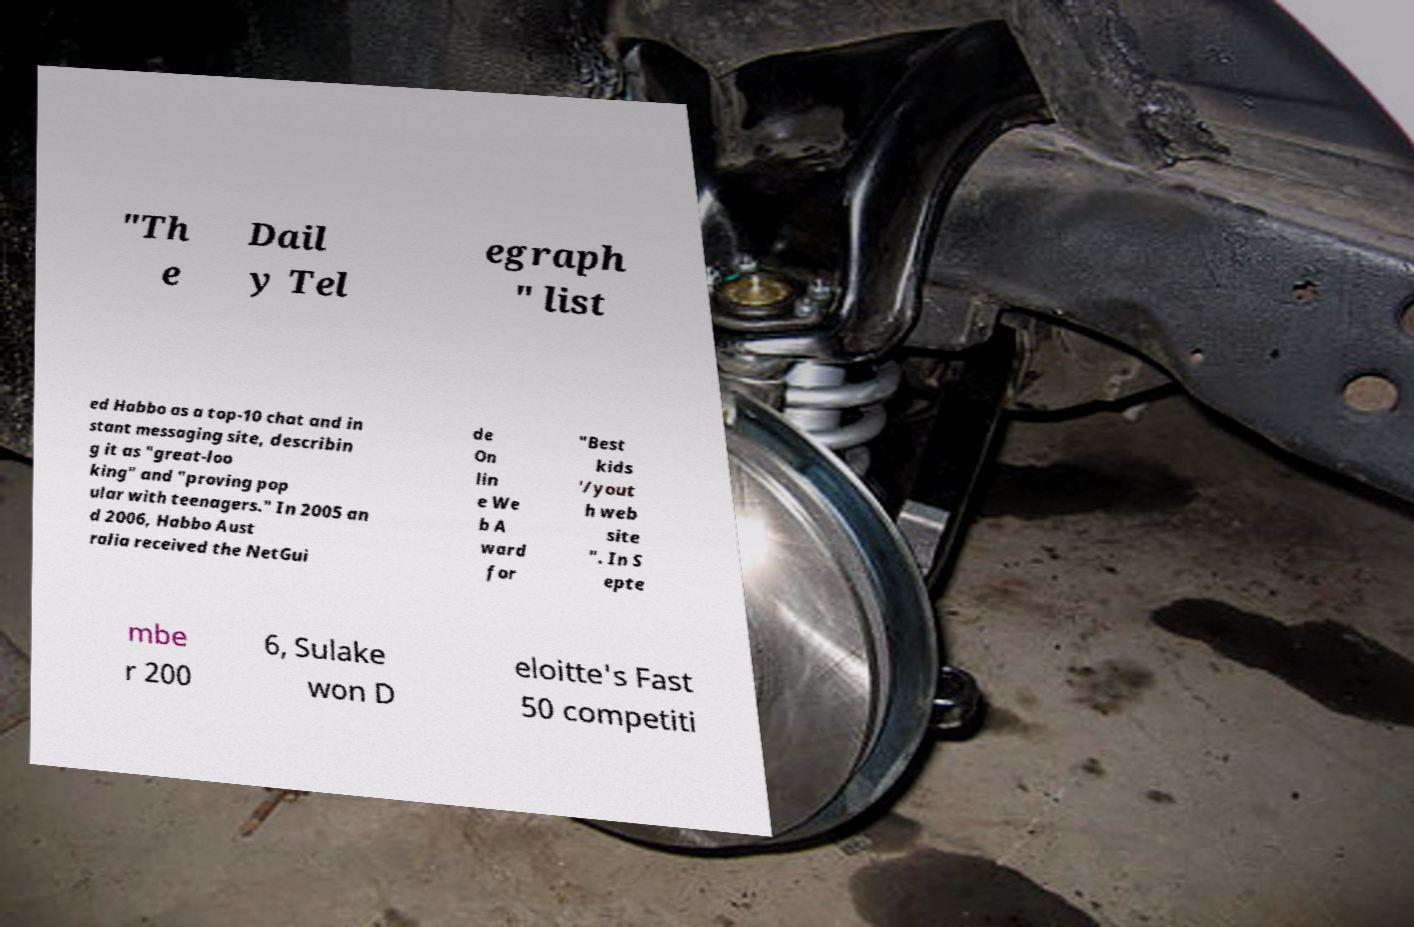Can you accurately transcribe the text from the provided image for me? "Th e Dail y Tel egraph " list ed Habbo as a top-10 chat and in stant messaging site, describin g it as "great-loo king" and "proving pop ular with teenagers." In 2005 an d 2006, Habbo Aust ralia received the NetGui de On lin e We b A ward for "Best kids '/yout h web site ". In S epte mbe r 200 6, Sulake won D eloitte's Fast 50 competiti 